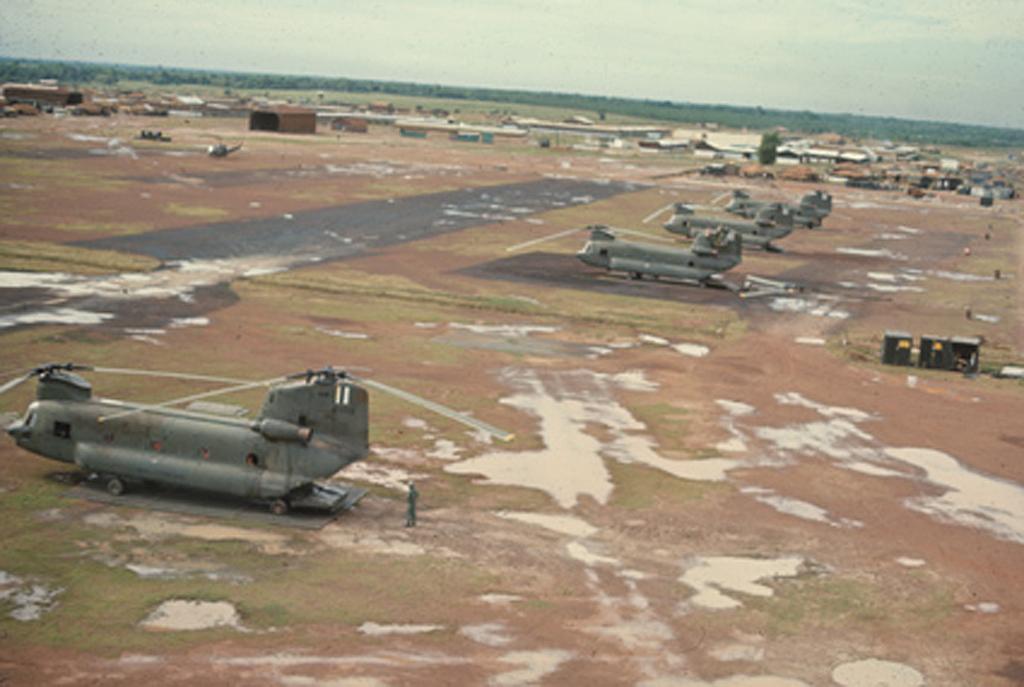Can you describe this image briefly? As we can see in the image there are planes and boxes here and there. In the background there are trees. On the top there is sky. 